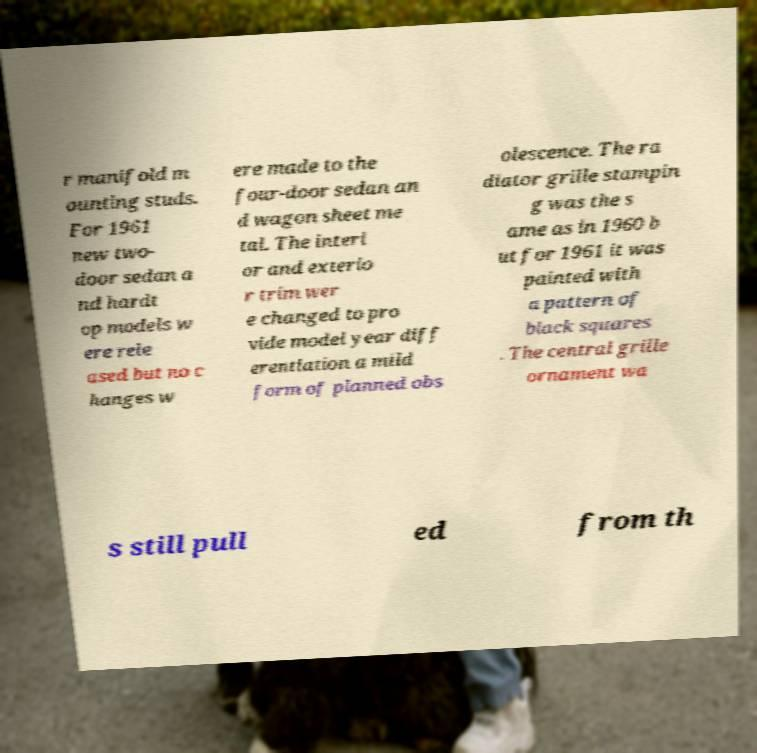Could you assist in decoding the text presented in this image and type it out clearly? r manifold m ounting studs. For 1961 new two- door sedan a nd hardt op models w ere rele ased but no c hanges w ere made to the four-door sedan an d wagon sheet me tal. The interi or and exterio r trim wer e changed to pro vide model year diff erentiation a mild form of planned obs olescence. The ra diator grille stampin g was the s ame as in 1960 b ut for 1961 it was painted with a pattern of black squares . The central grille ornament wa s still pull ed from th 